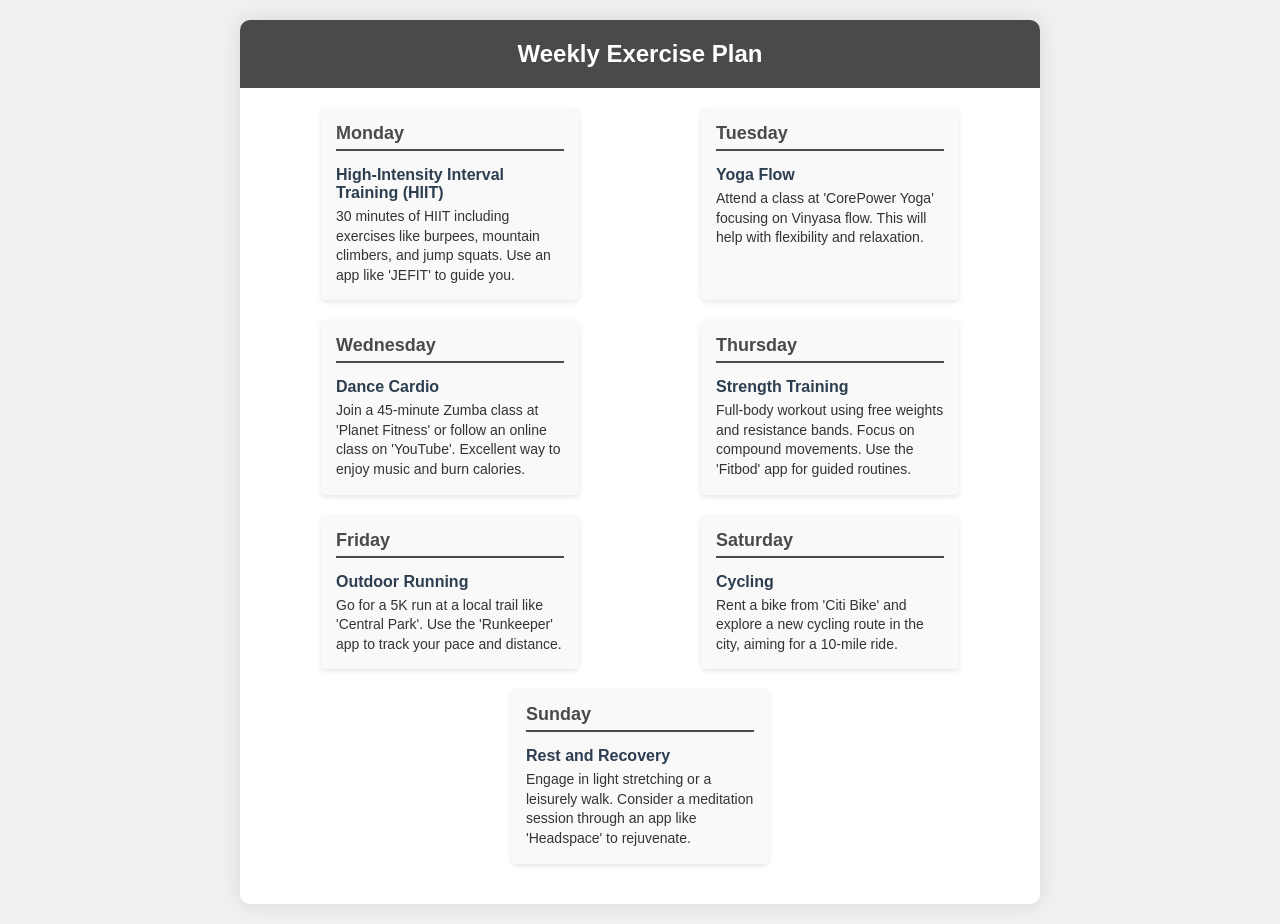What workout is scheduled for Monday? The workout scheduled for Monday is listed at the top of the Monday section of the document.
Answer: High-Intensity Interval Training (HIIT) How long is the Yoga Flow session on Tuesday? The duration of the Tuesday Yoga Flow session is mentioned in the details of the Tuesday section.
Answer: Not specified What type of cardio is featured on Wednesday? The specific type of cardio mentioned for Wednesday can be found in the details of that day.
Answer: Dance Cardio Which app is suggested for the strength training workout on Thursday? The document mentions a specific app for guidance during the strength training workout.
Answer: Fitbod What is the primary focus of the Saturday workout? The main activity for Saturday is described in the relevant section of the document.
Answer: Cycling How many minutes does the HIIT workout last? The duration of the HIIT workout is explicitly stated in the details of the Monday section.
Answer: 30 minutes What activity is recommended for Sunday? The activities suggested for Sunday are listed at the bottom of the Sunday section.
Answer: Rest and Recovery Which day features a dance class? The specific day that includes a dance class is indicated in that section of the schedule.
Answer: Wednesday What type of workout does Tuesday emphasize? The focus of the Tuesday workout is described in the title of that section, revealing its nature.
Answer: Yoga Flow 